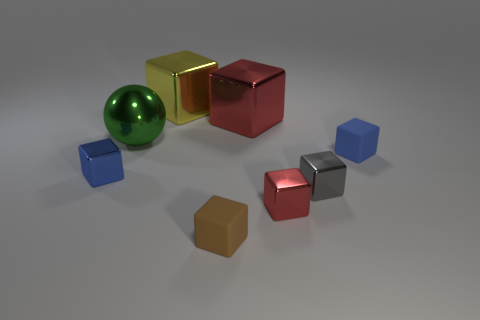Subtract 1 blocks. How many blocks are left? 6 Subtract all red blocks. How many blocks are left? 5 Subtract all red metallic cubes. How many cubes are left? 5 Subtract all green cubes. Subtract all green cylinders. How many cubes are left? 7 Add 1 tiny blue metallic objects. How many objects exist? 9 Subtract all blocks. How many objects are left? 1 Subtract all small blue cubes. Subtract all large red metallic cubes. How many objects are left? 5 Add 8 big yellow things. How many big yellow things are left? 9 Add 7 gray metal cubes. How many gray metal cubes exist? 8 Subtract 1 gray blocks. How many objects are left? 7 